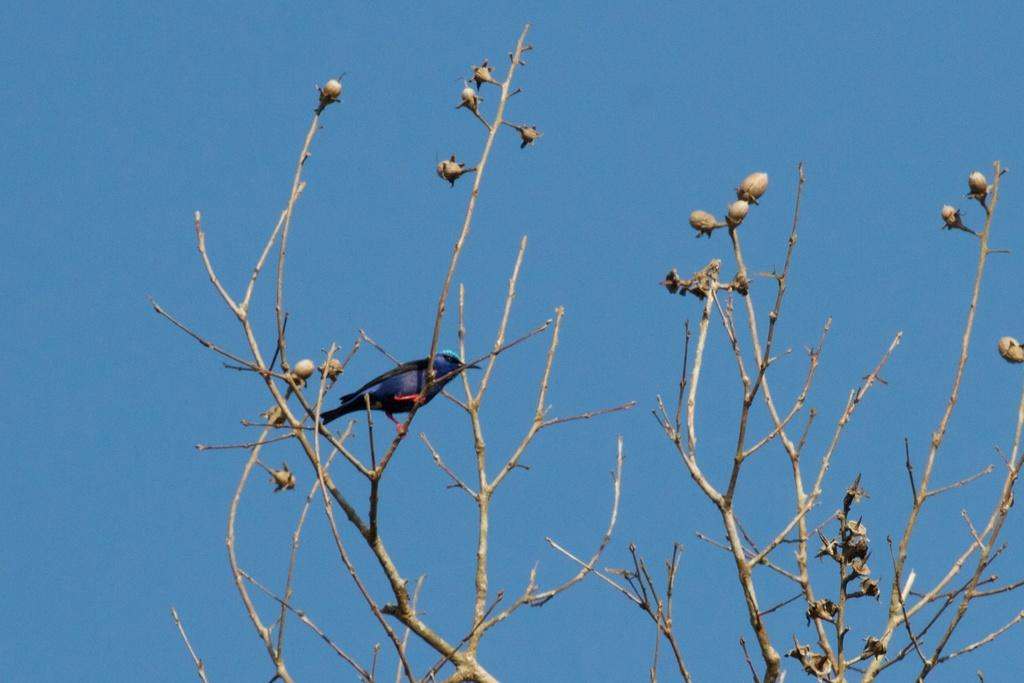What type of animal can be seen in the image? There is a bird in the image. Where is the bird located? The bird is on a tree. What is the condition of the sky in the image? The sky is clear in the image. What type of sack can be seen hanging from the bird's stomach in the image? There is no sack present in the image, nor is there any indication of a sack hanging from the bird's stomach. 